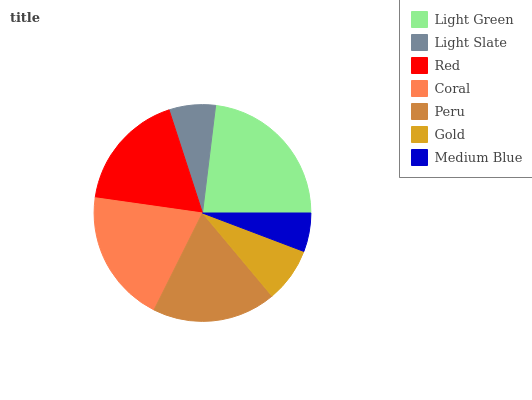Is Medium Blue the minimum?
Answer yes or no. Yes. Is Light Green the maximum?
Answer yes or no. Yes. Is Light Slate the minimum?
Answer yes or no. No. Is Light Slate the maximum?
Answer yes or no. No. Is Light Green greater than Light Slate?
Answer yes or no. Yes. Is Light Slate less than Light Green?
Answer yes or no. Yes. Is Light Slate greater than Light Green?
Answer yes or no. No. Is Light Green less than Light Slate?
Answer yes or no. No. Is Red the high median?
Answer yes or no. Yes. Is Red the low median?
Answer yes or no. Yes. Is Light Slate the high median?
Answer yes or no. No. Is Coral the low median?
Answer yes or no. No. 